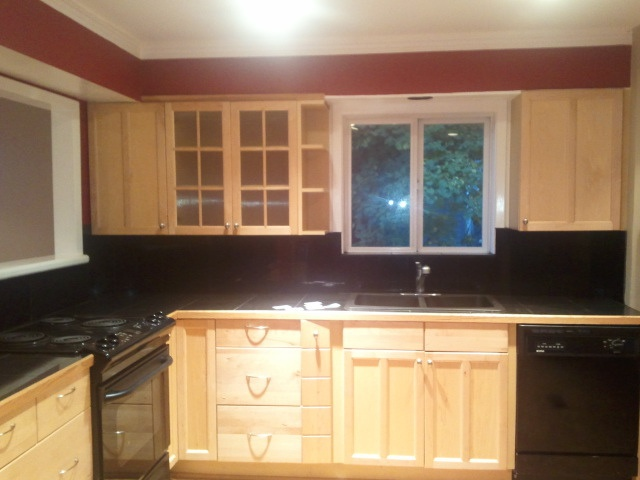Describe the objects in this image and their specific colors. I can see oven in maroon, black, and olive tones and sink in maroon, gray, black, and darkgray tones in this image. 